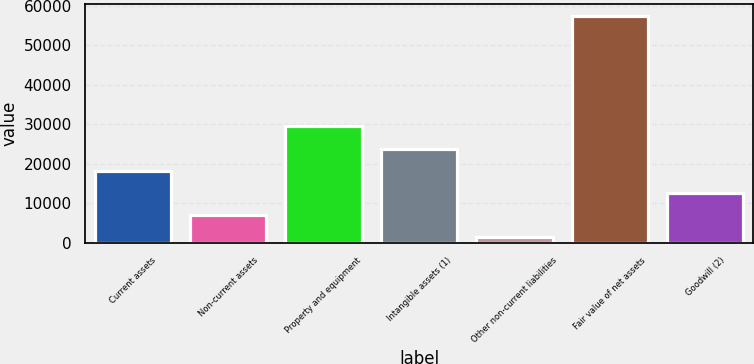<chart> <loc_0><loc_0><loc_500><loc_500><bar_chart><fcel>Current assets<fcel>Non-current assets<fcel>Property and equipment<fcel>Intangible assets (1)<fcel>Other non-current liabilities<fcel>Fair value of net assets<fcel>Goodwill (2)<nl><fcel>18205.1<fcel>6967.7<fcel>29442.5<fcel>23823.8<fcel>1349<fcel>57536<fcel>12586.4<nl></chart> 